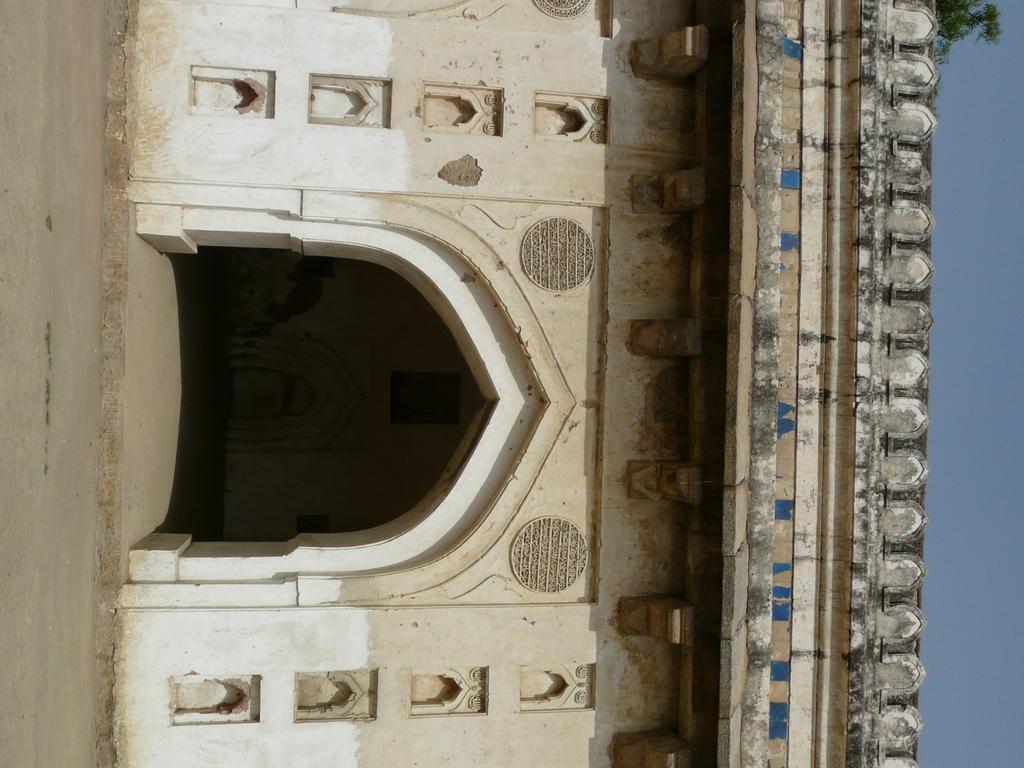Could you give a brief overview of what you see in this image? In this image I can see the ground, the building which is cream, blue, black and white in color and in the background I can see a tree and the sky. 